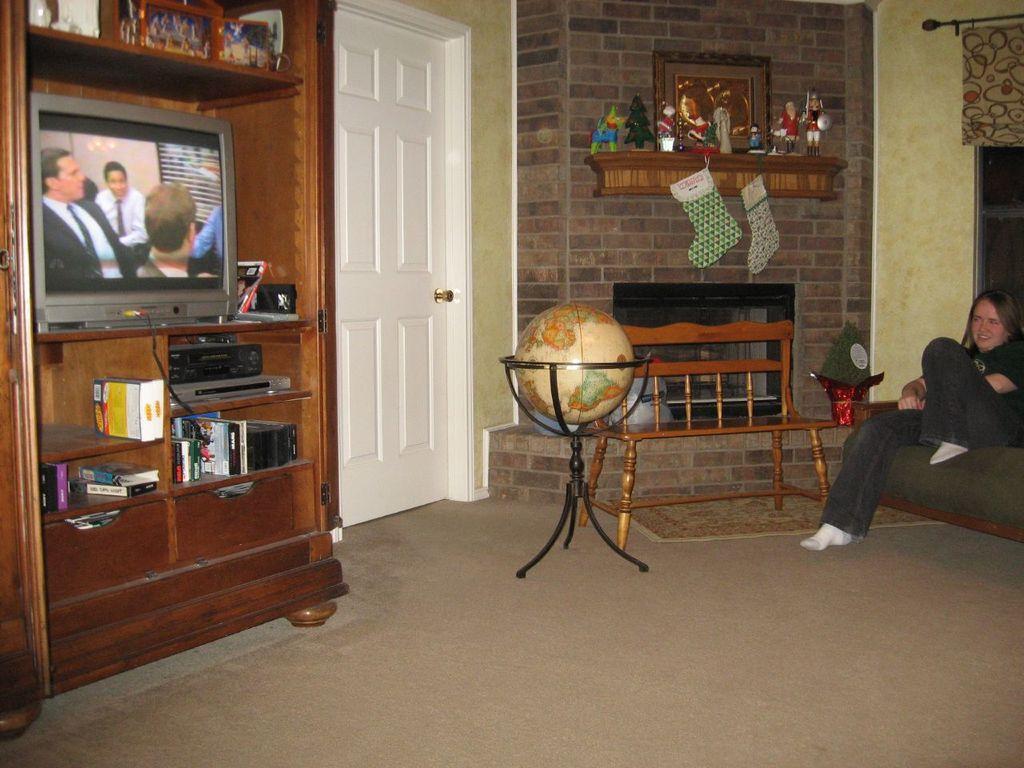Can you describe this image briefly? This is a picture taken in a room, the woman in black t shirt sitting on a sofa. In front of the woman there are the shelf on shelf there are books, television, and photo frame. To the right side of the shelf there is a white door and a table. 